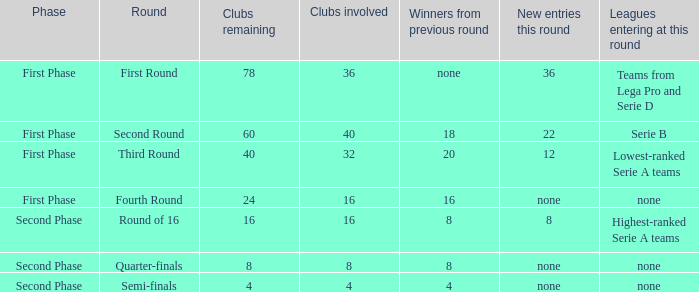Clubs involved is 8, what number would you find from winners from previous round? 8.0. 